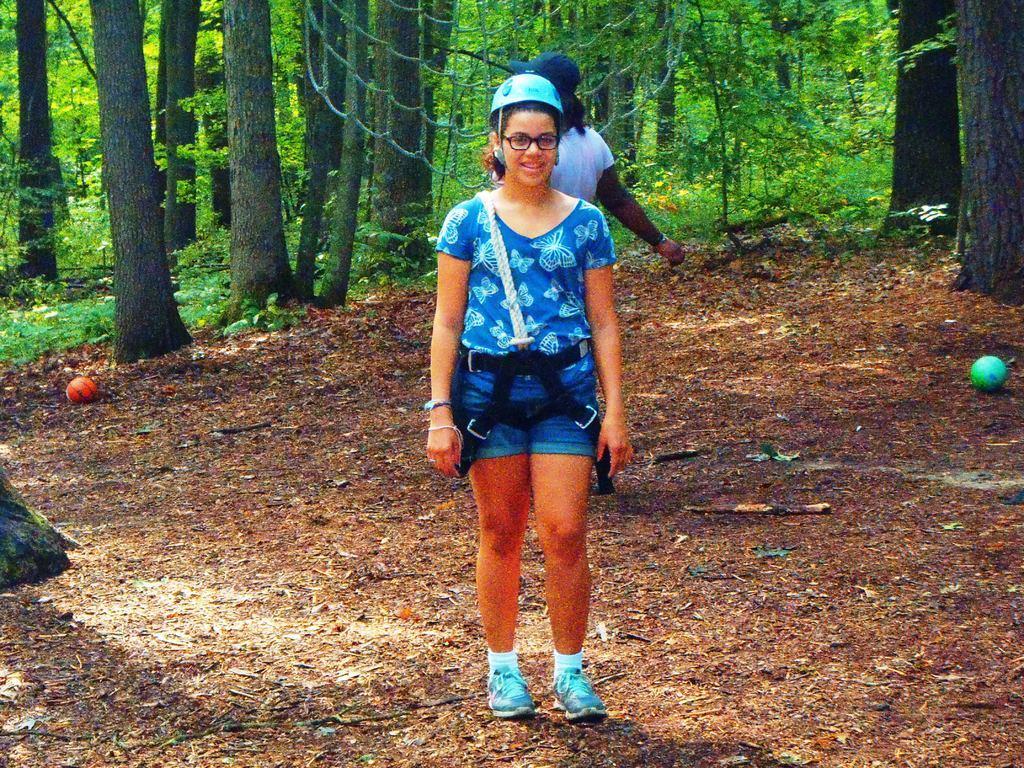Could you give a brief overview of what you see in this image? In this image there is a woman wearing a cap. She is standing on the land. Behind her there is a person wearing a cap. Top of the image there is a net hanging. There are balls on the land. Background there are trees and plants. 